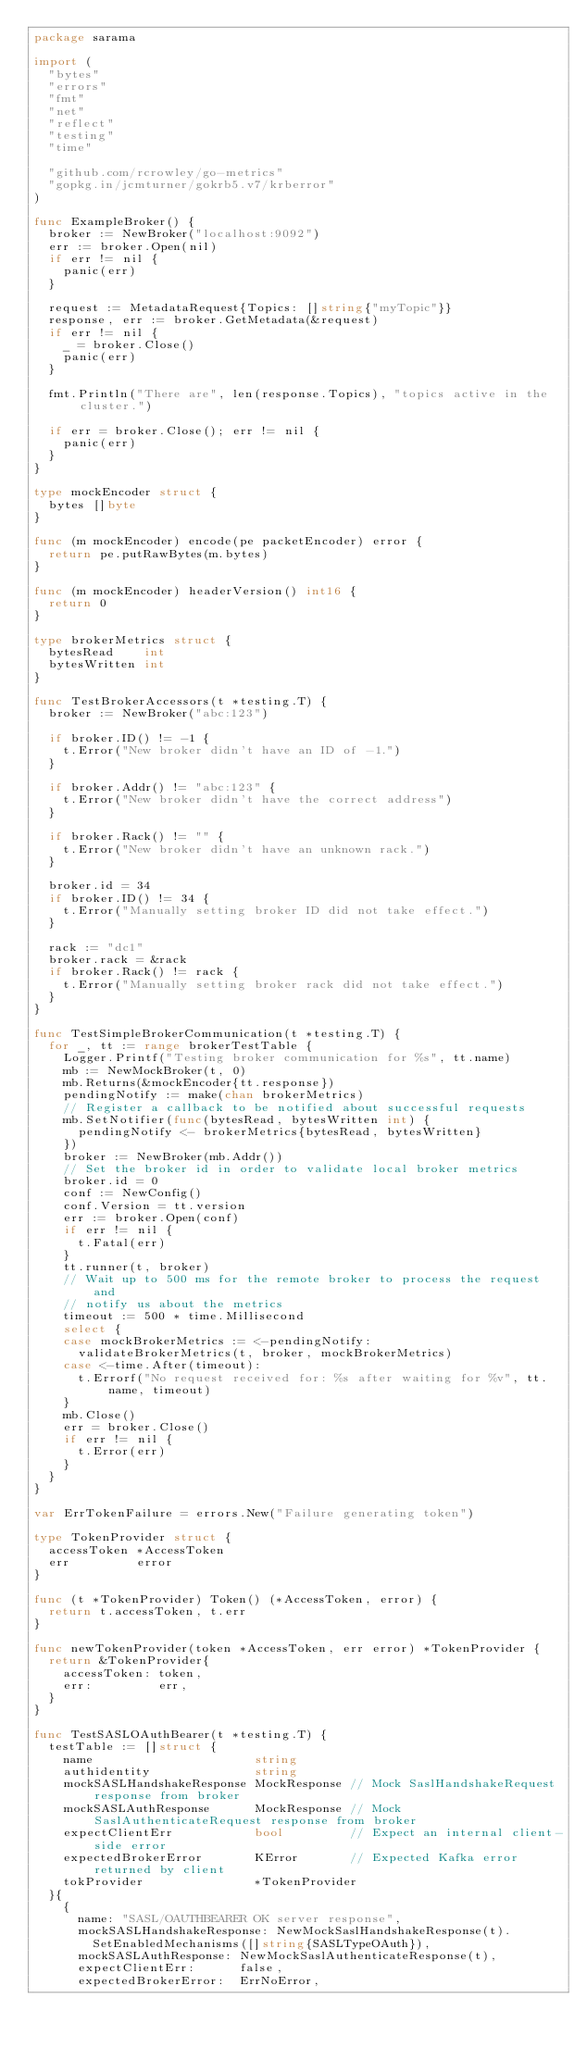<code> <loc_0><loc_0><loc_500><loc_500><_Go_>package sarama

import (
	"bytes"
	"errors"
	"fmt"
	"net"
	"reflect"
	"testing"
	"time"

	"github.com/rcrowley/go-metrics"
	"gopkg.in/jcmturner/gokrb5.v7/krberror"
)

func ExampleBroker() {
	broker := NewBroker("localhost:9092")
	err := broker.Open(nil)
	if err != nil {
		panic(err)
	}

	request := MetadataRequest{Topics: []string{"myTopic"}}
	response, err := broker.GetMetadata(&request)
	if err != nil {
		_ = broker.Close()
		panic(err)
	}

	fmt.Println("There are", len(response.Topics), "topics active in the cluster.")

	if err = broker.Close(); err != nil {
		panic(err)
	}
}

type mockEncoder struct {
	bytes []byte
}

func (m mockEncoder) encode(pe packetEncoder) error {
	return pe.putRawBytes(m.bytes)
}

func (m mockEncoder) headerVersion() int16 {
	return 0
}

type brokerMetrics struct {
	bytesRead    int
	bytesWritten int
}

func TestBrokerAccessors(t *testing.T) {
	broker := NewBroker("abc:123")

	if broker.ID() != -1 {
		t.Error("New broker didn't have an ID of -1.")
	}

	if broker.Addr() != "abc:123" {
		t.Error("New broker didn't have the correct address")
	}

	if broker.Rack() != "" {
		t.Error("New broker didn't have an unknown rack.")
	}

	broker.id = 34
	if broker.ID() != 34 {
		t.Error("Manually setting broker ID did not take effect.")
	}

	rack := "dc1"
	broker.rack = &rack
	if broker.Rack() != rack {
		t.Error("Manually setting broker rack did not take effect.")
	}
}

func TestSimpleBrokerCommunication(t *testing.T) {
	for _, tt := range brokerTestTable {
		Logger.Printf("Testing broker communication for %s", tt.name)
		mb := NewMockBroker(t, 0)
		mb.Returns(&mockEncoder{tt.response})
		pendingNotify := make(chan brokerMetrics)
		// Register a callback to be notified about successful requests
		mb.SetNotifier(func(bytesRead, bytesWritten int) {
			pendingNotify <- brokerMetrics{bytesRead, bytesWritten}
		})
		broker := NewBroker(mb.Addr())
		// Set the broker id in order to validate local broker metrics
		broker.id = 0
		conf := NewConfig()
		conf.Version = tt.version
		err := broker.Open(conf)
		if err != nil {
			t.Fatal(err)
		}
		tt.runner(t, broker)
		// Wait up to 500 ms for the remote broker to process the request and
		// notify us about the metrics
		timeout := 500 * time.Millisecond
		select {
		case mockBrokerMetrics := <-pendingNotify:
			validateBrokerMetrics(t, broker, mockBrokerMetrics)
		case <-time.After(timeout):
			t.Errorf("No request received for: %s after waiting for %v", tt.name, timeout)
		}
		mb.Close()
		err = broker.Close()
		if err != nil {
			t.Error(err)
		}
	}
}

var ErrTokenFailure = errors.New("Failure generating token")

type TokenProvider struct {
	accessToken *AccessToken
	err         error
}

func (t *TokenProvider) Token() (*AccessToken, error) {
	return t.accessToken, t.err
}

func newTokenProvider(token *AccessToken, err error) *TokenProvider {
	return &TokenProvider{
		accessToken: token,
		err:         err,
	}
}

func TestSASLOAuthBearer(t *testing.T) {
	testTable := []struct {
		name                      string
		authidentity              string
		mockSASLHandshakeResponse MockResponse // Mock SaslHandshakeRequest response from broker
		mockSASLAuthResponse      MockResponse // Mock SaslAuthenticateRequest response from broker
		expectClientErr           bool         // Expect an internal client-side error
		expectedBrokerError       KError       // Expected Kafka error returned by client
		tokProvider               *TokenProvider
	}{
		{
			name: "SASL/OAUTHBEARER OK server response",
			mockSASLHandshakeResponse: NewMockSaslHandshakeResponse(t).
				SetEnabledMechanisms([]string{SASLTypeOAuth}),
			mockSASLAuthResponse: NewMockSaslAuthenticateResponse(t),
			expectClientErr:      false,
			expectedBrokerError:  ErrNoError,</code> 